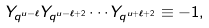<formula> <loc_0><loc_0><loc_500><loc_500>Y _ { q ^ { u - \ell } } Y _ { q ^ { u - \ell + 2 } } \cdots Y _ { q ^ { u + \ell + 2 } } \equiv - 1 ,</formula> 